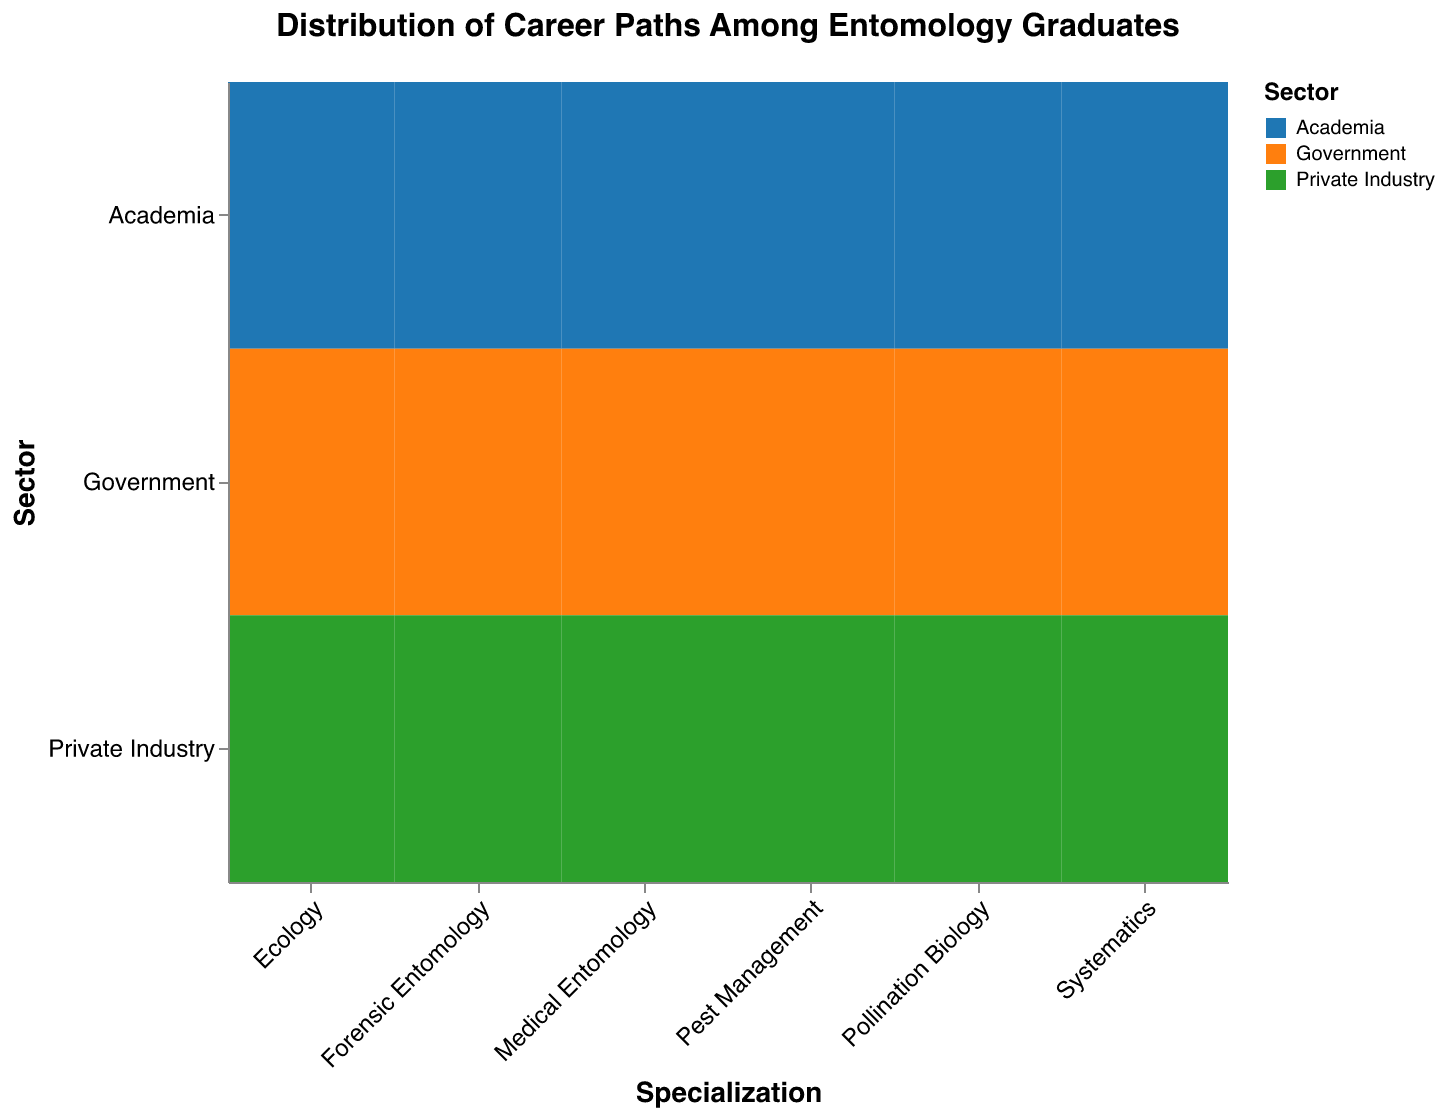What is the title of the Mosaic Plot? The title is typically found at the top of the Mosaic Plot, and in this case, it is explicitly stated in the provided code.
Answer: Distribution of Career Paths Among Entomology Graduates Which specialization has the highest number of graduates working in Private Industry? Check the counts under each specialization for the sector labeled 'Private Industry' to identify the maximum value. Pest Management has the highest count with 50.
Answer: Pest Management How many graduates are employed in Academia across all specializations? Sum the counts of graduates in the 'Academia' sector for all specializations. The sum is 45 + 35 + 20 + 30 + 15 + 25 = 170.
Answer: 170 What is the proportion of graduates in Ecology going to Academia versus Government? Find the counts for Ecology in both sectors and calculate the ratio. For Ecology, Academia has 45 and Government has 30. The ratio is 45/30 = 1.5.
Answer: 1.5 Which specialization has the lowest number of graduates in Private Industry? Compare the counts in the 'Private Industry' sector across all specializations. Forensic Entomology has the lowest with 10.
Answer: Forensic Entomology Are there more graduates in Pollination Biology working in Private Industry than in Government? Compare the counts for Pollination Biology in Private Industry (35) and Government (25). Yes, 35 is greater than 25.
Answer: Yes How many specializations have more than 30 graduates working in Government? Count the specializations with Government sector counts greater than 30. These are Pest Management (40) and Medical Entomology (35). There are 2 specializations.
Answer: 2 Which sector employs the most graduates from Systematics? Compare the counts in different sectors for Systematics. The highest is Academia with 35 graduates.
Answer: Academia What is the total number of graduates who specialized in Medical Entomology? Sum the counts across all sectors for Medical Entomology. 25 (Academia) + 35 (Government) + 20 (Private Industry) = 80.
Answer: 80 Is the number of graduates in Pest Management working in Academia greater than those in Private Industry for Systematics? Compare the counts. Pest Management in Academia has 20, and Systematics in Private Industry has 15. Yes, 20 is greater than 15.
Answer: Yes 